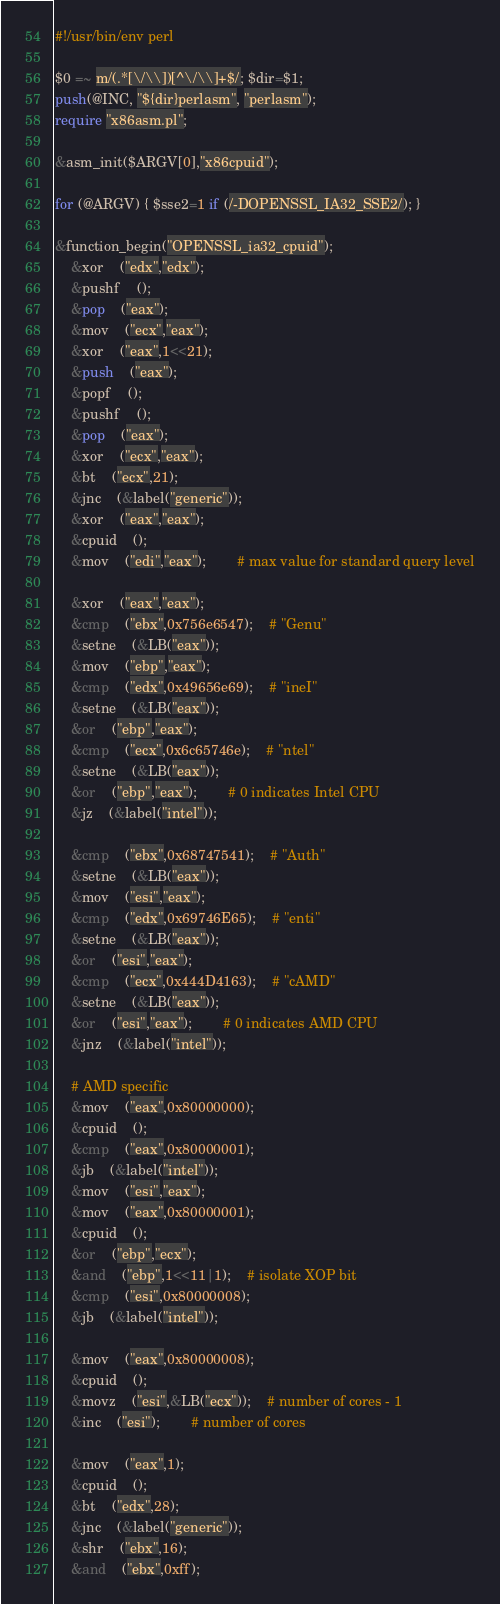Convert code to text. <code><loc_0><loc_0><loc_500><loc_500><_Perl_>#!/usr/bin/env perl

$0 =~ m/(.*[\/\\])[^\/\\]+$/; $dir=$1;
push(@INC, "${dir}perlasm", "perlasm");
require "x86asm.pl";

&asm_init($ARGV[0],"x86cpuid");

for (@ARGV) { $sse2=1 if (/-DOPENSSL_IA32_SSE2/); }

&function_begin("OPENSSL_ia32_cpuid");
	&xor	("edx","edx");
	&pushf	();
	&pop	("eax");
	&mov	("ecx","eax");
	&xor	("eax",1<<21);
	&push	("eax");
	&popf	();
	&pushf	();
	&pop	("eax");
	&xor	("ecx","eax");
	&bt	("ecx",21);
	&jnc	(&label("generic"));
	&xor	("eax","eax");
	&cpuid	();
	&mov	("edi","eax");		# max value for standard query level

	&xor	("eax","eax");
	&cmp	("ebx",0x756e6547);	# "Genu"
	&setne	(&LB("eax"));
	&mov	("ebp","eax");
	&cmp	("edx",0x49656e69);	# "ineI"
	&setne	(&LB("eax"));
	&or	("ebp","eax");
	&cmp	("ecx",0x6c65746e);	# "ntel"
	&setne	(&LB("eax"));
	&or	("ebp","eax");		# 0 indicates Intel CPU
	&jz	(&label("intel"));

	&cmp	("ebx",0x68747541);	# "Auth"
	&setne	(&LB("eax"));
	&mov	("esi","eax");
	&cmp	("edx",0x69746E65);	# "enti"
	&setne	(&LB("eax"));
	&or	("esi","eax");
	&cmp	("ecx",0x444D4163);	# "cAMD"
	&setne	(&LB("eax"));
	&or	("esi","eax");		# 0 indicates AMD CPU
	&jnz	(&label("intel"));

	# AMD specific
	&mov	("eax",0x80000000);
	&cpuid	();
	&cmp	("eax",0x80000001);
	&jb	(&label("intel"));
	&mov	("esi","eax");
	&mov	("eax",0x80000001);
	&cpuid	();
	&or	("ebp","ecx");
	&and	("ebp",1<<11|1);	# isolate XOP bit
	&cmp	("esi",0x80000008);
	&jb	(&label("intel"));

	&mov	("eax",0x80000008);
	&cpuid	();
	&movz	("esi",&LB("ecx"));	# number of cores - 1
	&inc	("esi");		# number of cores

	&mov	("eax",1);
	&cpuid	();
	&bt	("edx",28);
	&jnc	(&label("generic"));
	&shr	("ebx",16);
	&and	("ebx",0xff);</code> 